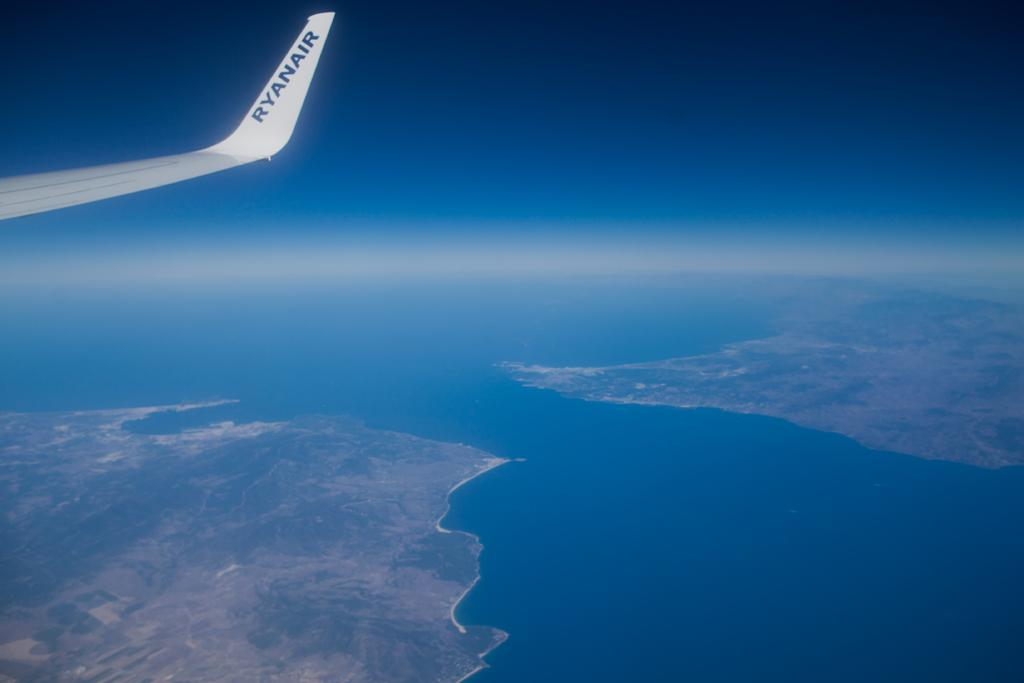What is the perspective of the image? The image is taken from a plane. What part of the plane can be seen in the image? There is a wing of the plane visible in the image. What is located at the bottom of the image? There is an ocean and land at the bottom of the image. What is the color of the sky in the image? The sky appears blue in color. Can you see any feet walking on the land in the image? There are no feet or people walking visible in the image. What type of animal can be seen swimming in the ocean in the image? There are no animals visible in the image, as it only shows the wing of the plane, the ocean, and the land. 